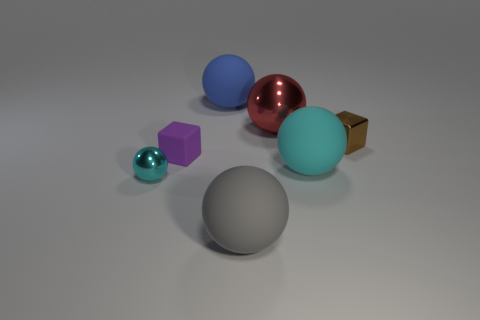Subtract all gray matte spheres. How many spheres are left? 4 Subtract all blue balls. How many balls are left? 4 Subtract all cubes. How many objects are left? 5 Add 3 large purple rubber balls. How many objects exist? 10 Subtract 0 brown cylinders. How many objects are left? 7 Subtract 3 spheres. How many spheres are left? 2 Subtract all cyan balls. Subtract all cyan cylinders. How many balls are left? 3 Subtract all gray cylinders. How many green blocks are left? 0 Subtract all large green cylinders. Subtract all brown things. How many objects are left? 6 Add 5 blue rubber spheres. How many blue rubber spheres are left? 6 